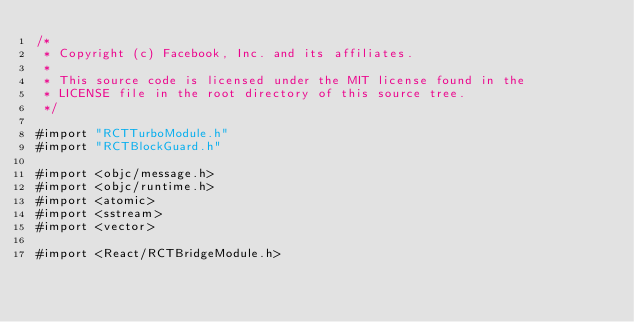Convert code to text. <code><loc_0><loc_0><loc_500><loc_500><_ObjectiveC_>/*
 * Copyright (c) Facebook, Inc. and its affiliates.
 *
 * This source code is licensed under the MIT license found in the
 * LICENSE file in the root directory of this source tree.
 */

#import "RCTTurboModule.h"
#import "RCTBlockGuard.h"

#import <objc/message.h>
#import <objc/runtime.h>
#import <atomic>
#import <sstream>
#import <vector>

#import <React/RCTBridgeModule.h></code> 